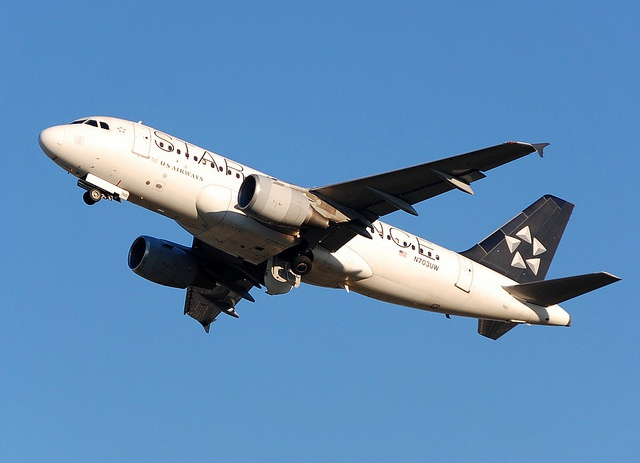Describe the objects in this image and their specific colors. I can see a airplane in gray, black, ivory, and tan tones in this image. 